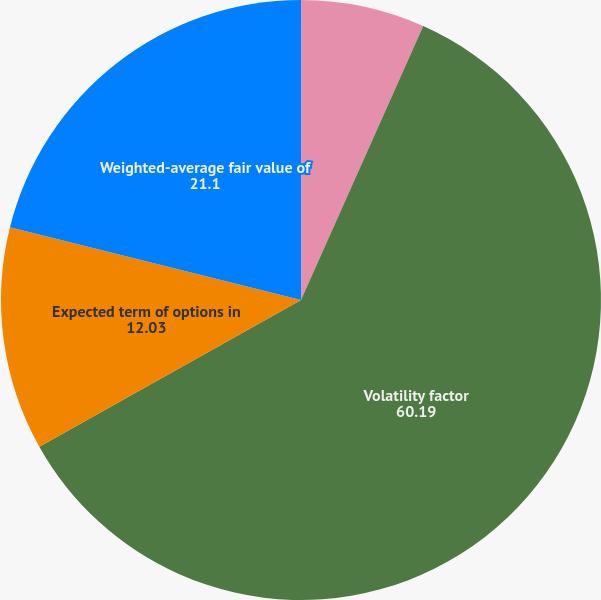<chart> <loc_0><loc_0><loc_500><loc_500><pie_chart><fcel>Risk-free interest rate<fcel>Volatility factor<fcel>Expected term of options in<fcel>Weighted-average fair value of<nl><fcel>6.68%<fcel>60.19%<fcel>12.03%<fcel>21.1%<nl></chart> 